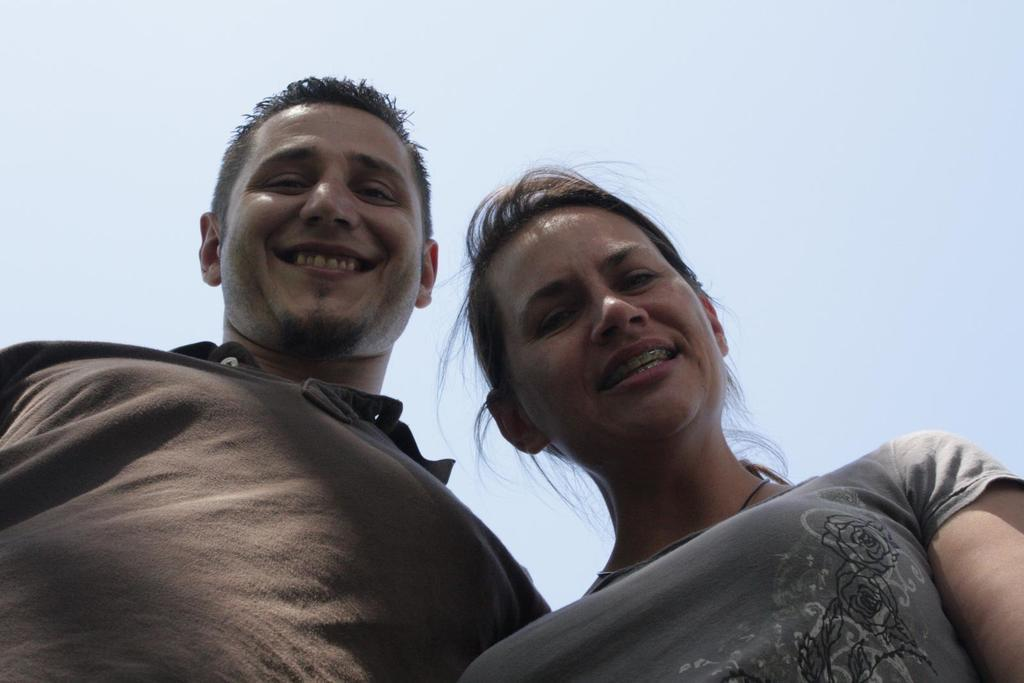What is the gender of the person in the image? There is a man and a woman in the image. What expression do the people in the image have? The man and the woman are both smiling. What type of coil is being used by the queen in the image? There is no queen or coil present in the image; it features a man and a woman who are both smiling. 